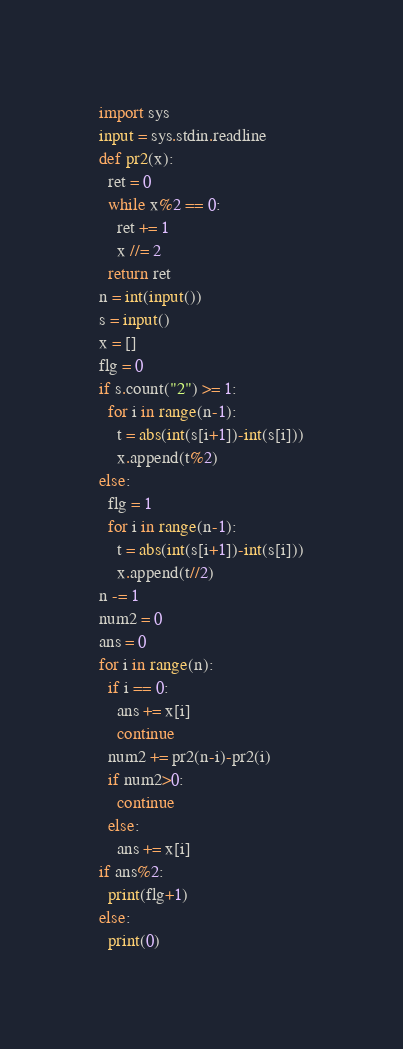<code> <loc_0><loc_0><loc_500><loc_500><_Python_>import sys
input = sys.stdin.readline
def pr2(x):
  ret = 0
  while x%2 == 0:
    ret += 1
    x //= 2
  return ret
n = int(input())
s = input()
x = []
flg = 0
if s.count("2") >= 1:
  for i in range(n-1):
    t = abs(int(s[i+1])-int(s[i]))
    x.append(t%2)
else:
  flg = 1
  for i in range(n-1):
    t = abs(int(s[i+1])-int(s[i]))
    x.append(t//2)
n -= 1
num2 = 0
ans = 0
for i in range(n):
  if i == 0:
    ans += x[i]
    continue
  num2 += pr2(n-i)-pr2(i)
  if num2>0:
    continue
  else:
    ans += x[i]
if ans%2:
  print(flg+1)
else:
  print(0)</code> 